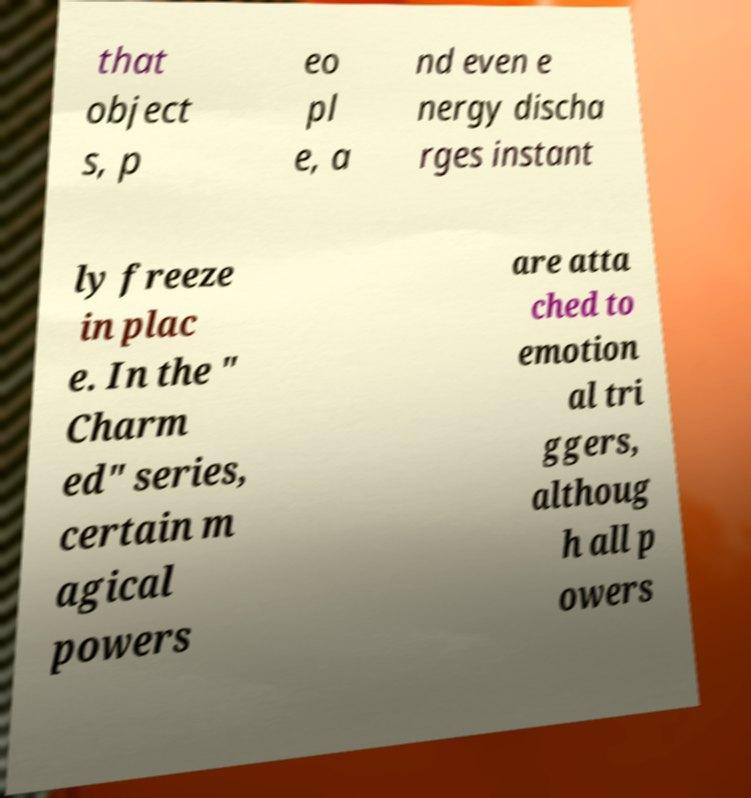Please read and relay the text visible in this image. What does it say? that object s, p eo pl e, a nd even e nergy discha rges instant ly freeze in plac e. In the " Charm ed" series, certain m agical powers are atta ched to emotion al tri ggers, althoug h all p owers 